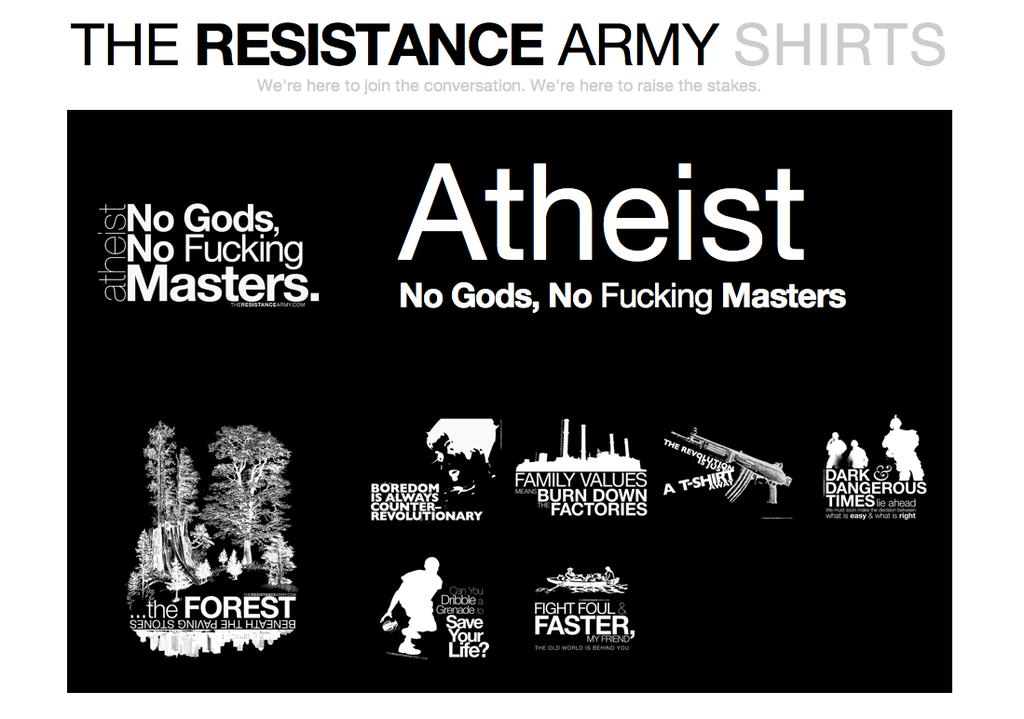What type of content is shown in the image? There is information depicted in the image. Are there any individuals shown in the image? Yes, there are people depicted in the image. What object can be seen in the image that might be used as a weapon? A gun is visible in the image. What type of natural environment is depicted in the image? There are trees depicted in the image. What type of man-made structure is depicted in the image? There is a factory depicted in the image. How many cows are depicted in the image? There are no cows depicted in the image. What step is being taken by the people in the image? There is no indication of any specific steps being taken by the people in the image. 